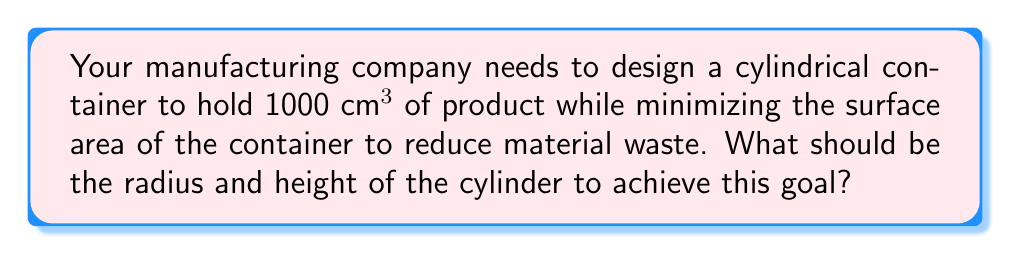Can you solve this math problem? Let's approach this step-by-step using calculus and optimization:

1) Let $r$ be the radius and $h$ be the height of the cylinder.

2) The volume of a cylinder is given by $V = \pi r^2 h$. We're told this should equal 1000 cm³:

   $$\pi r^2 h = 1000$$

3) The surface area of a cylinder (including top and bottom) is given by:

   $$S = 2\pi r^2 + 2\pi rh$$

4) We want to minimize S. From step 2, we can express h in terms of r:

   $$h = \frac{1000}{\pi r^2}$$

5) Substituting this into the surface area equation:

   $$S = 2\pi r^2 + 2\pi r(\frac{1000}{\pi r^2}) = 2\pi r^2 + \frac{2000}{r}$$

6) To find the minimum, we differentiate S with respect to r and set it to zero:

   $$\frac{dS}{dr} = 4\pi r - \frac{2000}{r^2} = 0$$

7) Solving this equation:

   $$4\pi r^3 = 2000$$
   $$r^3 = \frac{500}{\pi}$$
   $$r = \sqrt[3]{\frac{500}{\pi}} \approx 5.42 \text{ cm}$$

8) We can find h by substituting this value of r back into the equation from step 4:

   $$h = \frac{1000}{\pi (\sqrt[3]{\frac{500}{\pi}})^2} \approx 10.84 \text{ cm}$$

9) We can verify that $\pi r^2 h \approx 1000 \text{ cm}^3$

[asy]
import geometry;

size(200);
real r = 5.42;
real h = 10.84;

path base = circle((0,0), r);
path top = circle((0,h), r);
draw(base);
draw(top);
draw((r,0)--(r,h));
draw((-r,0)--(-r,h));
label("r", (r/2,0), E);
label("h", (r,h/2), E);

</asy]
Answer: Radius ≈ 5.42 cm, Height ≈ 10.84 cm 